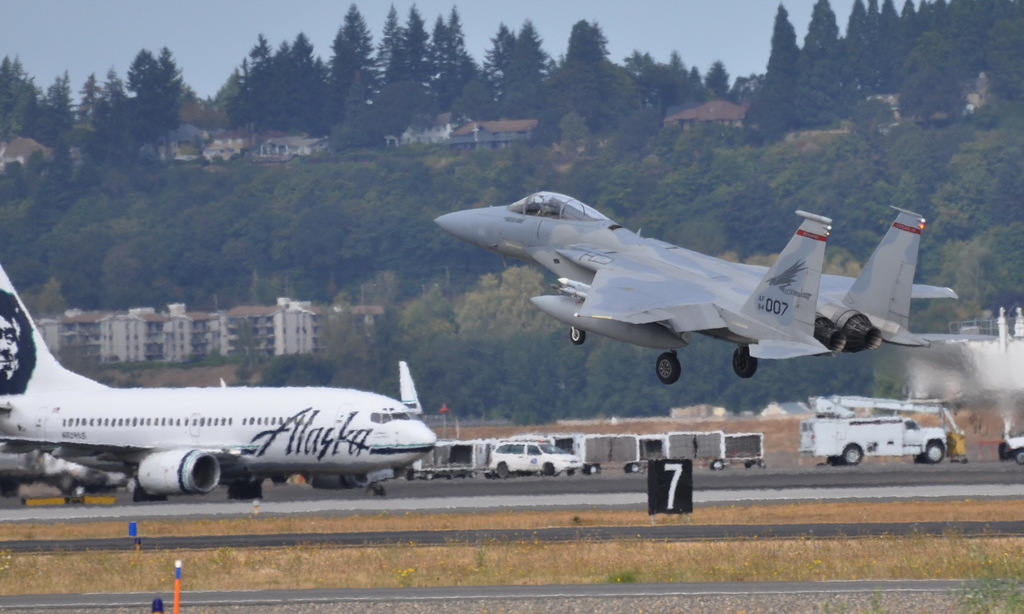Describe the main differences between the two aircraft visible in the image. The image features an F-15 military jet with a twin-engine and combat design taking off powerfully, contrasted with a commercial Alaska Airlines 737 which is designed for passenger transport and is stationary on the tarmac. Could you explain why a fighter jet might be taking off next to commercial airlines? It's likely an airshow or a joint military-civil aviation exercise. Such events display military aircraft capabilities and enhance coordination between military and civil sectors in aviation. 